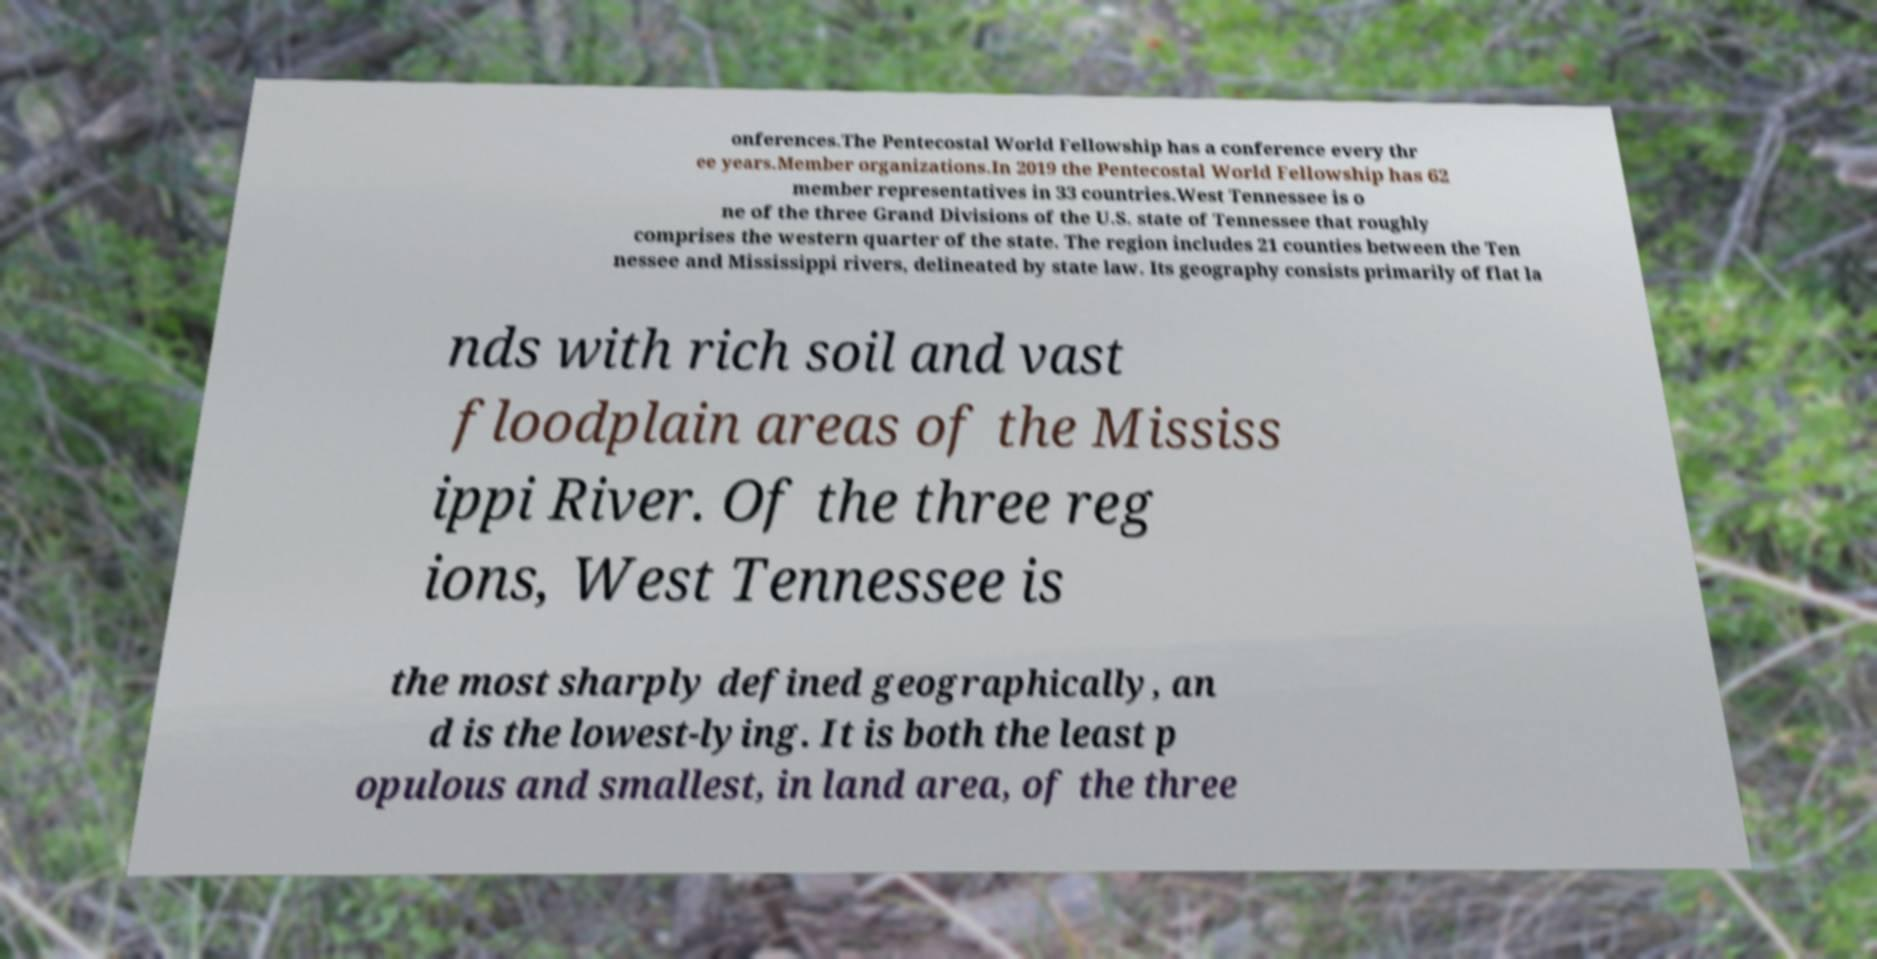What messages or text are displayed in this image? I need them in a readable, typed format. onferences.The Pentecostal World Fellowship has a conference every thr ee years.Member organizations.In 2019 the Pentecostal World Fellowship has 62 member representatives in 33 countries.West Tennessee is o ne of the three Grand Divisions of the U.S. state of Tennessee that roughly comprises the western quarter of the state. The region includes 21 counties between the Ten nessee and Mississippi rivers, delineated by state law. Its geography consists primarily of flat la nds with rich soil and vast floodplain areas of the Mississ ippi River. Of the three reg ions, West Tennessee is the most sharply defined geographically, an d is the lowest-lying. It is both the least p opulous and smallest, in land area, of the three 